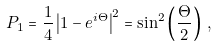<formula> <loc_0><loc_0><loc_500><loc_500>P _ { 1 } = \frac { 1 } { 4 } \left | 1 - e ^ { i \Theta } \right | ^ { 2 } = \sin ^ { 2 } \left ( \frac { \Theta } { 2 } \right ) \, ,</formula> 